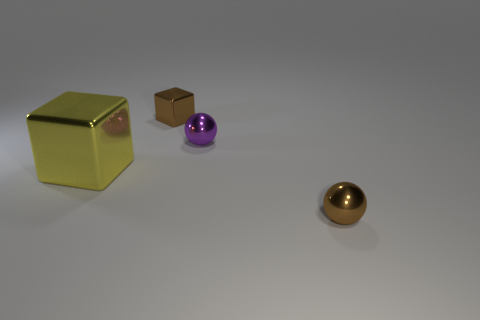The metallic thing that is on the right side of the purple metal thing is what color?
Your answer should be compact. Brown. Does the block behind the purple metallic sphere have the same size as the sphere behind the large yellow cube?
Ensure brevity in your answer.  Yes. How many objects are brown metal balls or blocks?
Provide a short and direct response. 3. What is the big thing in front of the metallic block behind the big block made of?
Your answer should be very brief. Metal. What number of purple objects are the same shape as the big yellow object?
Offer a terse response. 0. Is there a tiny shiny object of the same color as the tiny block?
Ensure brevity in your answer.  Yes. What number of things are either small things that are left of the tiny purple object or big yellow cubes in front of the tiny purple thing?
Make the answer very short. 2. Is there a tiny purple metal thing that is behind the brown object in front of the yellow shiny cube?
Give a very brief answer. Yes. The brown shiny object that is the same size as the brown metal sphere is what shape?
Keep it short and to the point. Cube. How many things are either shiny cubes that are to the left of the small brown shiny block or tiny spheres?
Give a very brief answer. 3. 